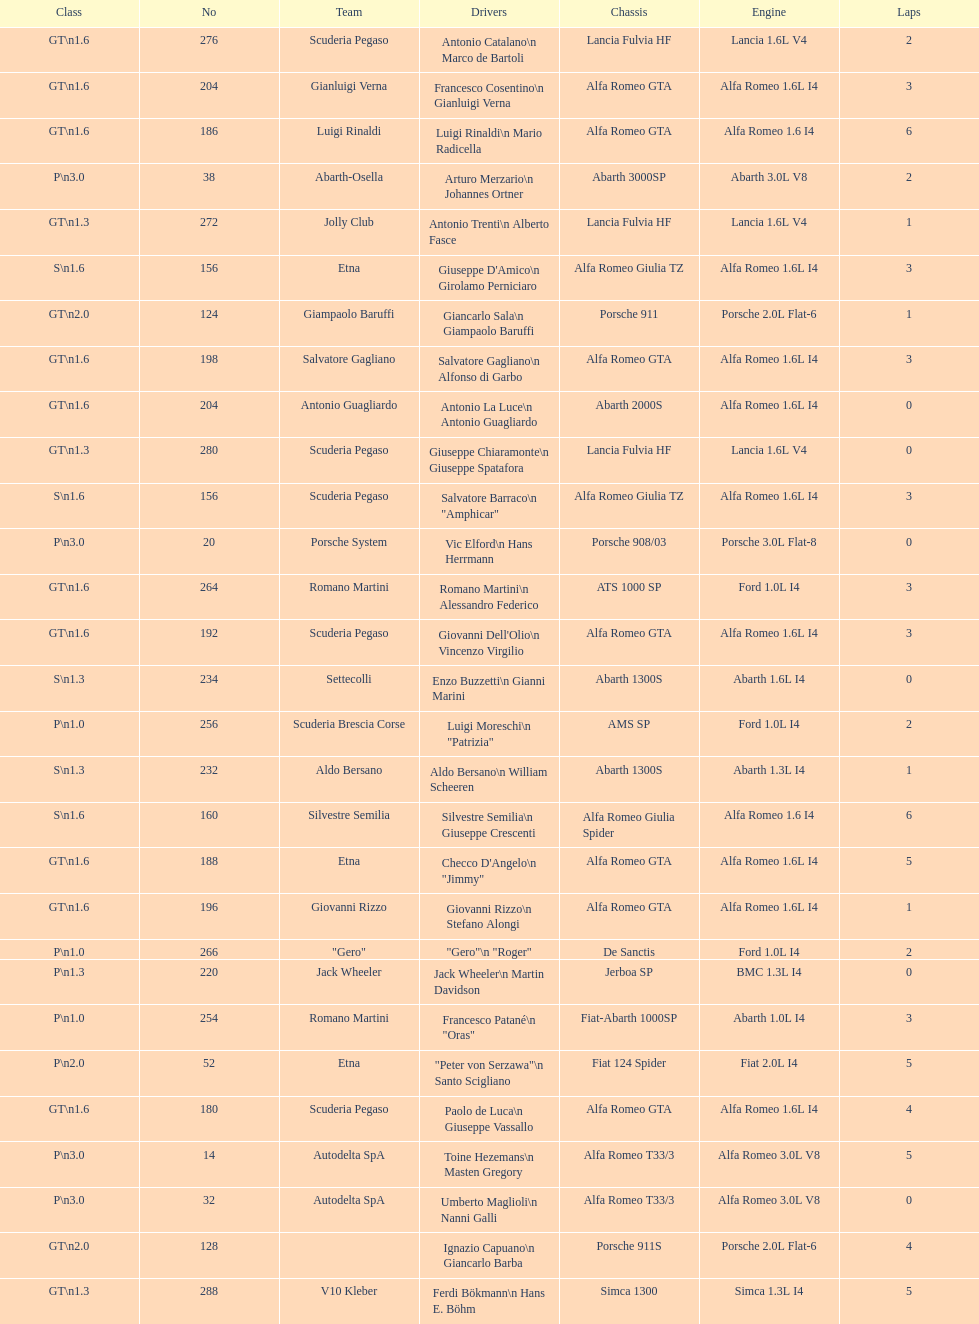What class is below s 1.6? GT 1.6. 